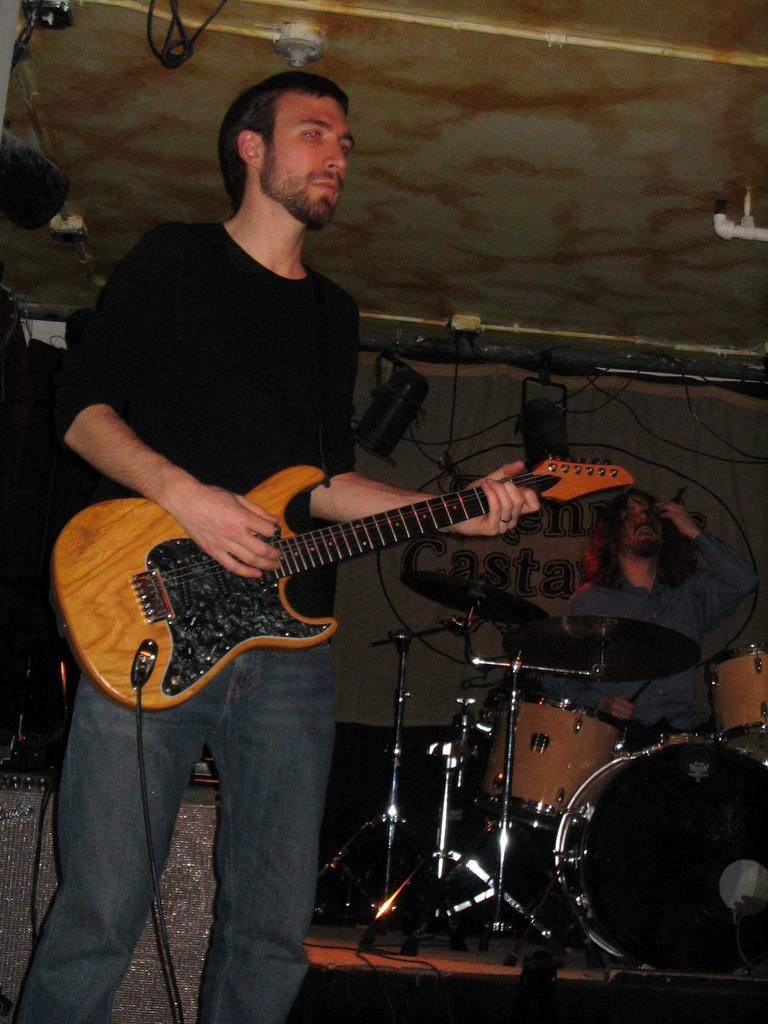Could you give a brief overview of what you see in this image? In this picture we can see two men, a man in the front is standing and playing a guitar, a man in the background is playing drums, we can see cymbals and drums on the right side, there is the ceiling at the top of the picture. 